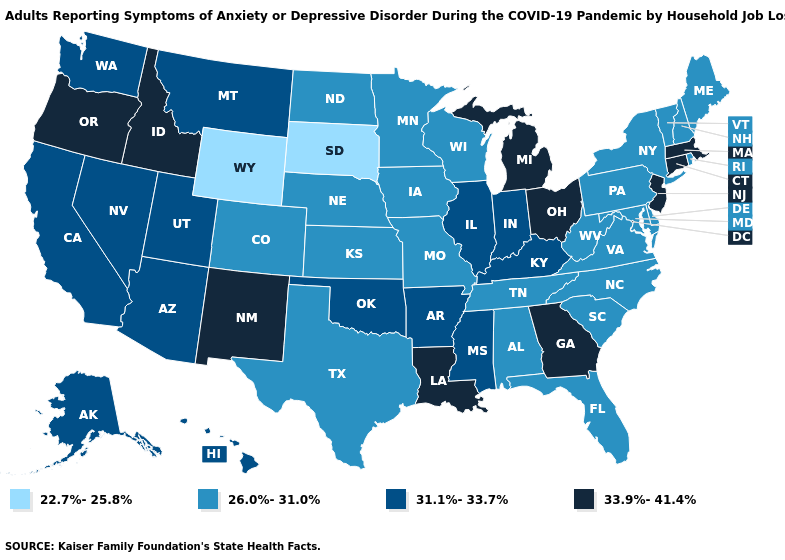Name the states that have a value in the range 31.1%-33.7%?
Give a very brief answer. Alaska, Arizona, Arkansas, California, Hawaii, Illinois, Indiana, Kentucky, Mississippi, Montana, Nevada, Oklahoma, Utah, Washington. Name the states that have a value in the range 26.0%-31.0%?
Concise answer only. Alabama, Colorado, Delaware, Florida, Iowa, Kansas, Maine, Maryland, Minnesota, Missouri, Nebraska, New Hampshire, New York, North Carolina, North Dakota, Pennsylvania, Rhode Island, South Carolina, Tennessee, Texas, Vermont, Virginia, West Virginia, Wisconsin. What is the value of Alaska?
Keep it brief. 31.1%-33.7%. Does the map have missing data?
Short answer required. No. Name the states that have a value in the range 33.9%-41.4%?
Short answer required. Connecticut, Georgia, Idaho, Louisiana, Massachusetts, Michigan, New Jersey, New Mexico, Ohio, Oregon. Which states have the lowest value in the MidWest?
Write a very short answer. South Dakota. Does the map have missing data?
Write a very short answer. No. Does Illinois have the lowest value in the MidWest?
Give a very brief answer. No. Is the legend a continuous bar?
Short answer required. No. Does Missouri have the lowest value in the MidWest?
Quick response, please. No. Among the states that border Alabama , does Mississippi have the lowest value?
Give a very brief answer. No. Does Oklahoma have the lowest value in the USA?
Concise answer only. No. Name the states that have a value in the range 22.7%-25.8%?
Short answer required. South Dakota, Wyoming. Among the states that border Delaware , does Pennsylvania have the highest value?
Answer briefly. No. 